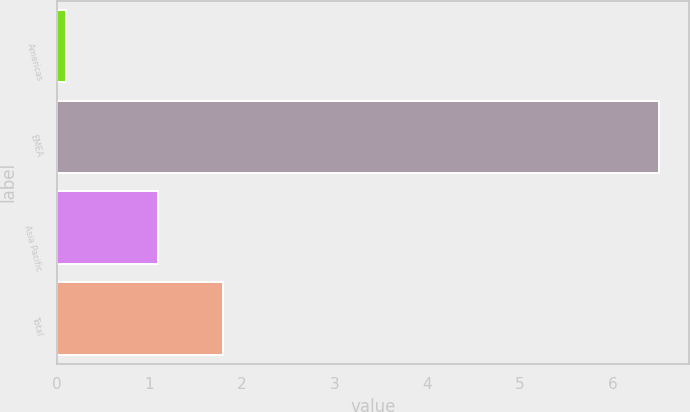<chart> <loc_0><loc_0><loc_500><loc_500><bar_chart><fcel>Americas<fcel>EMEA<fcel>Asia Pacific<fcel>Total<nl><fcel>0.1<fcel>6.5<fcel>1.1<fcel>1.8<nl></chart> 